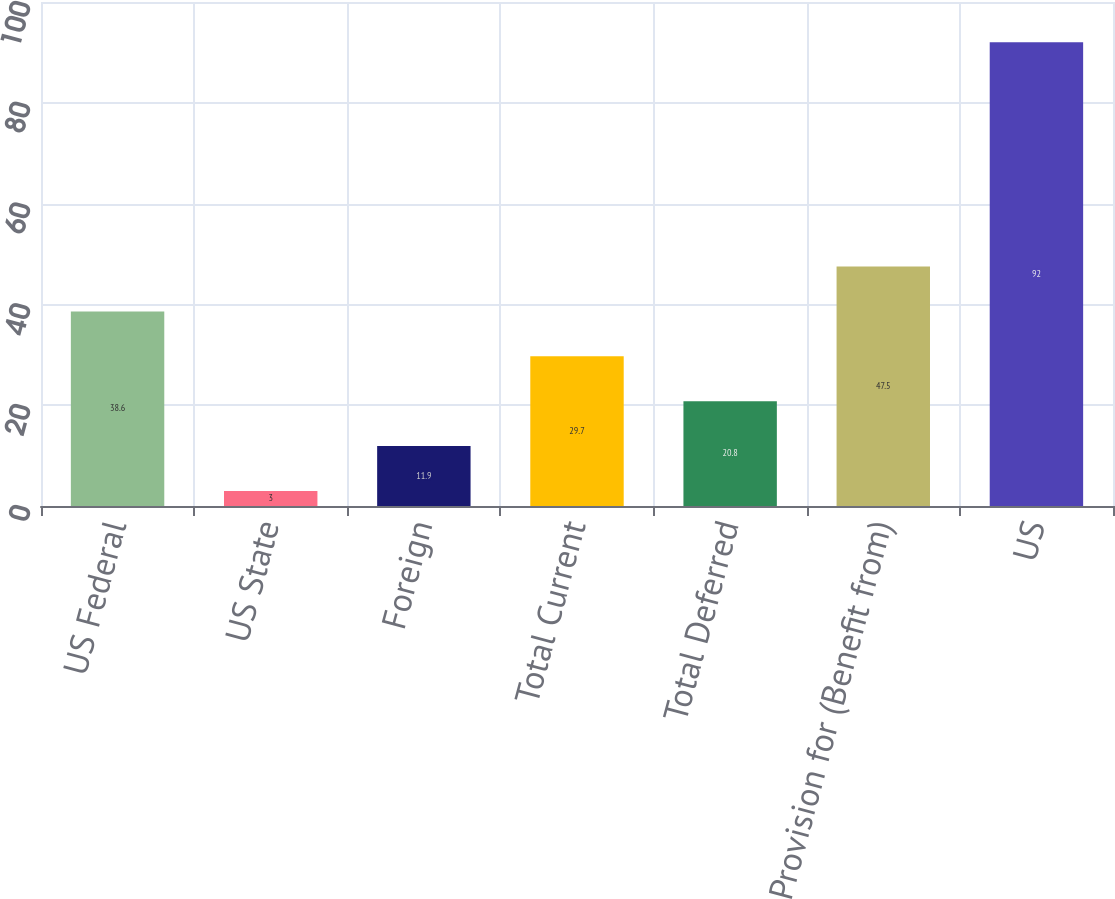<chart> <loc_0><loc_0><loc_500><loc_500><bar_chart><fcel>US Federal<fcel>US State<fcel>Foreign<fcel>Total Current<fcel>Total Deferred<fcel>Provision for (Benefit from)<fcel>US<nl><fcel>38.6<fcel>3<fcel>11.9<fcel>29.7<fcel>20.8<fcel>47.5<fcel>92<nl></chart> 